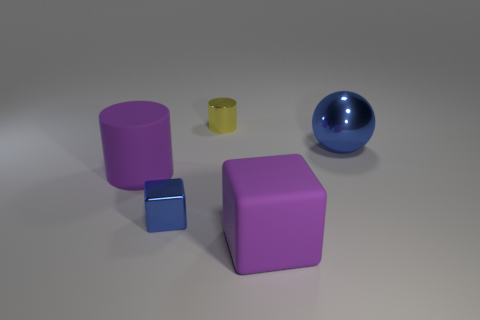How big is the purple rubber thing on the left side of the matte thing that is to the right of the tiny cylinder?
Your answer should be very brief. Large. There is a tiny thing in front of the large shiny object; is it the same color as the sphere?
Offer a terse response. Yes. What is the shape of the big object that is the same color as the big cube?
Keep it short and to the point. Cylinder. How many other blue things have the same shape as the tiny blue object?
Keep it short and to the point. 0. There is a ball that is the same material as the yellow thing; what is its size?
Your answer should be very brief. Large. Are there the same number of big matte cubes that are behind the shiny ball and blue shiny balls?
Give a very brief answer. No. Does the big ball have the same color as the small shiny cube?
Provide a succinct answer. Yes. Is the shape of the rubber thing behind the matte cube the same as the tiny metal thing that is on the right side of the tiny metallic block?
Offer a terse response. Yes. There is another thing that is the same shape as the tiny blue thing; what is it made of?
Your answer should be very brief. Rubber. There is a big thing that is behind the shiny block and on the left side of the blue ball; what color is it?
Offer a very short reply. Purple. 